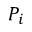<formula> <loc_0><loc_0><loc_500><loc_500>P _ { i }</formula> 